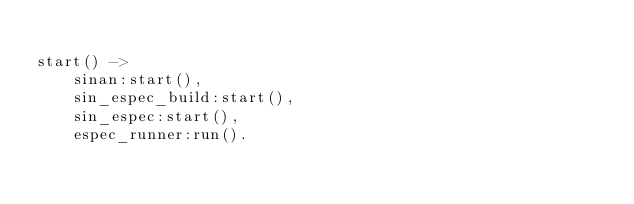Convert code to text. <code><loc_0><loc_0><loc_500><loc_500><_Erlang_>
start() ->
    sinan:start(),
    sin_espec_build:start(),
    sin_espec:start(),
    espec_runner:run().
</code> 